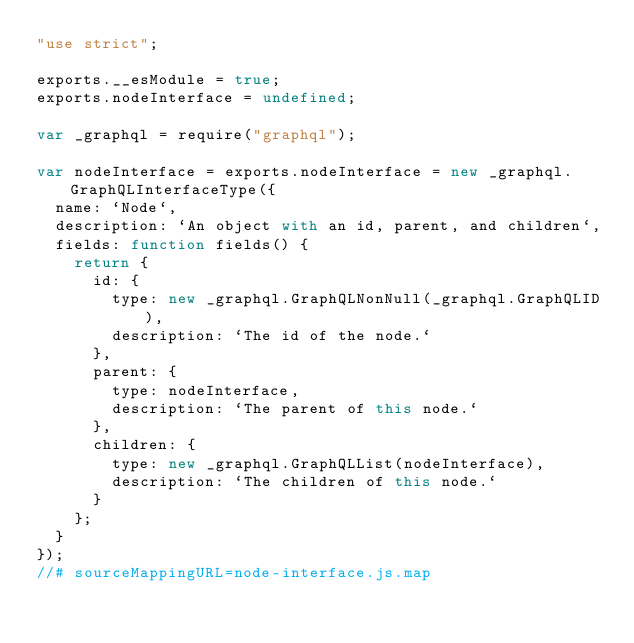Convert code to text. <code><loc_0><loc_0><loc_500><loc_500><_JavaScript_>"use strict";

exports.__esModule = true;
exports.nodeInterface = undefined;

var _graphql = require("graphql");

var nodeInterface = exports.nodeInterface = new _graphql.GraphQLInterfaceType({
  name: `Node`,
  description: `An object with an id, parent, and children`,
  fields: function fields() {
    return {
      id: {
        type: new _graphql.GraphQLNonNull(_graphql.GraphQLID),
        description: `The id of the node.`
      },
      parent: {
        type: nodeInterface,
        description: `The parent of this node.`
      },
      children: {
        type: new _graphql.GraphQLList(nodeInterface),
        description: `The children of this node.`
      }
    };
  }
});
//# sourceMappingURL=node-interface.js.map</code> 